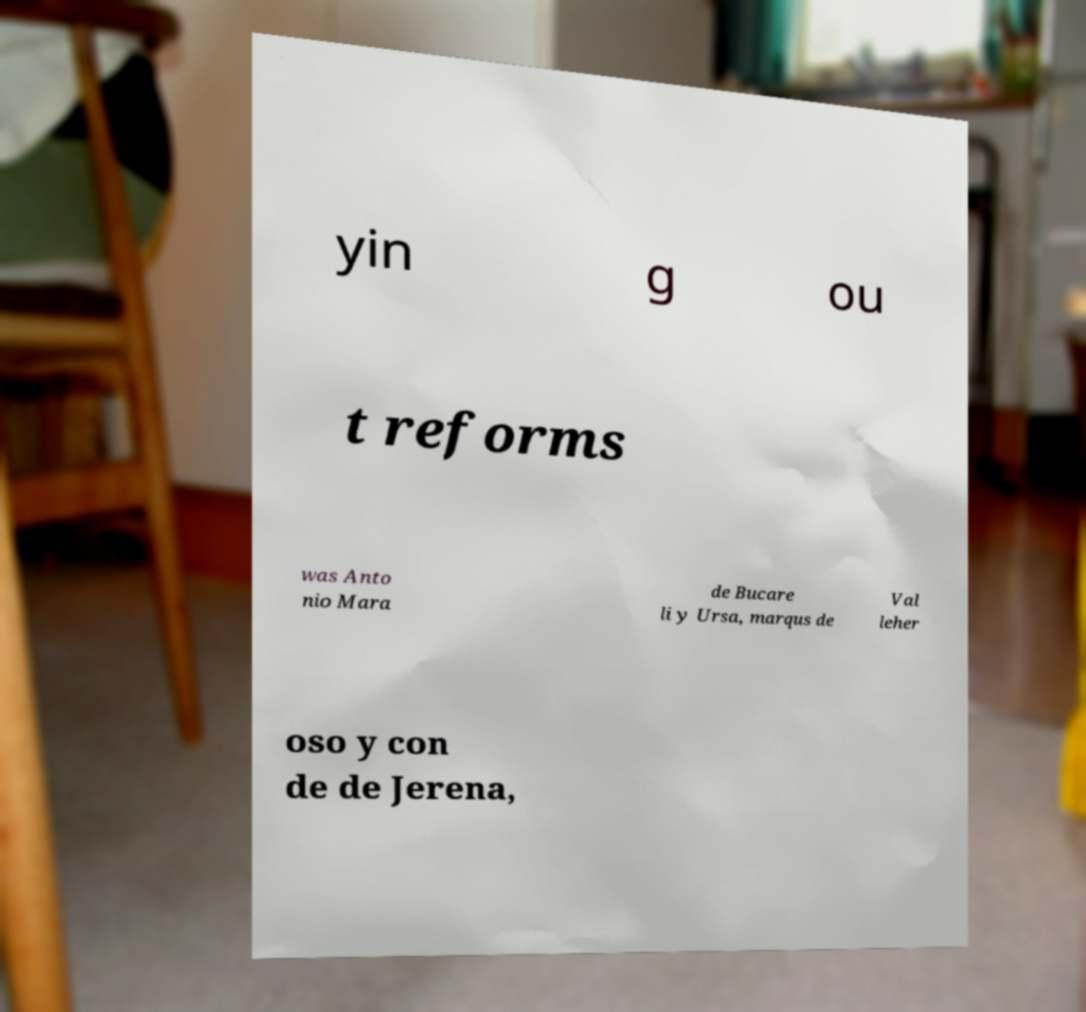Can you accurately transcribe the text from the provided image for me? yin g ou t reforms was Anto nio Mara de Bucare li y Ursa, marqus de Val leher oso y con de de Jerena, 